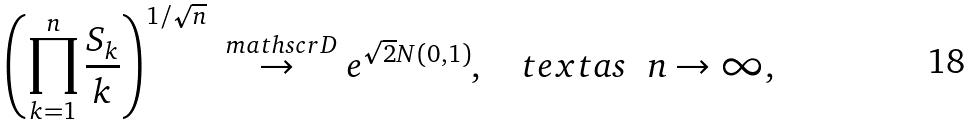Convert formula to latex. <formula><loc_0><loc_0><loc_500><loc_500>\left ( \prod _ { k = 1 } ^ { n } \frac { S _ { k } } { k } \right ) ^ { 1 / \sqrt { n } } \overset { \ m a t h s c r D } \to e ^ { \sqrt { 2 } N ( 0 , 1 ) } , \quad t e x t { a s } \ \ n \to \infty ,</formula> 